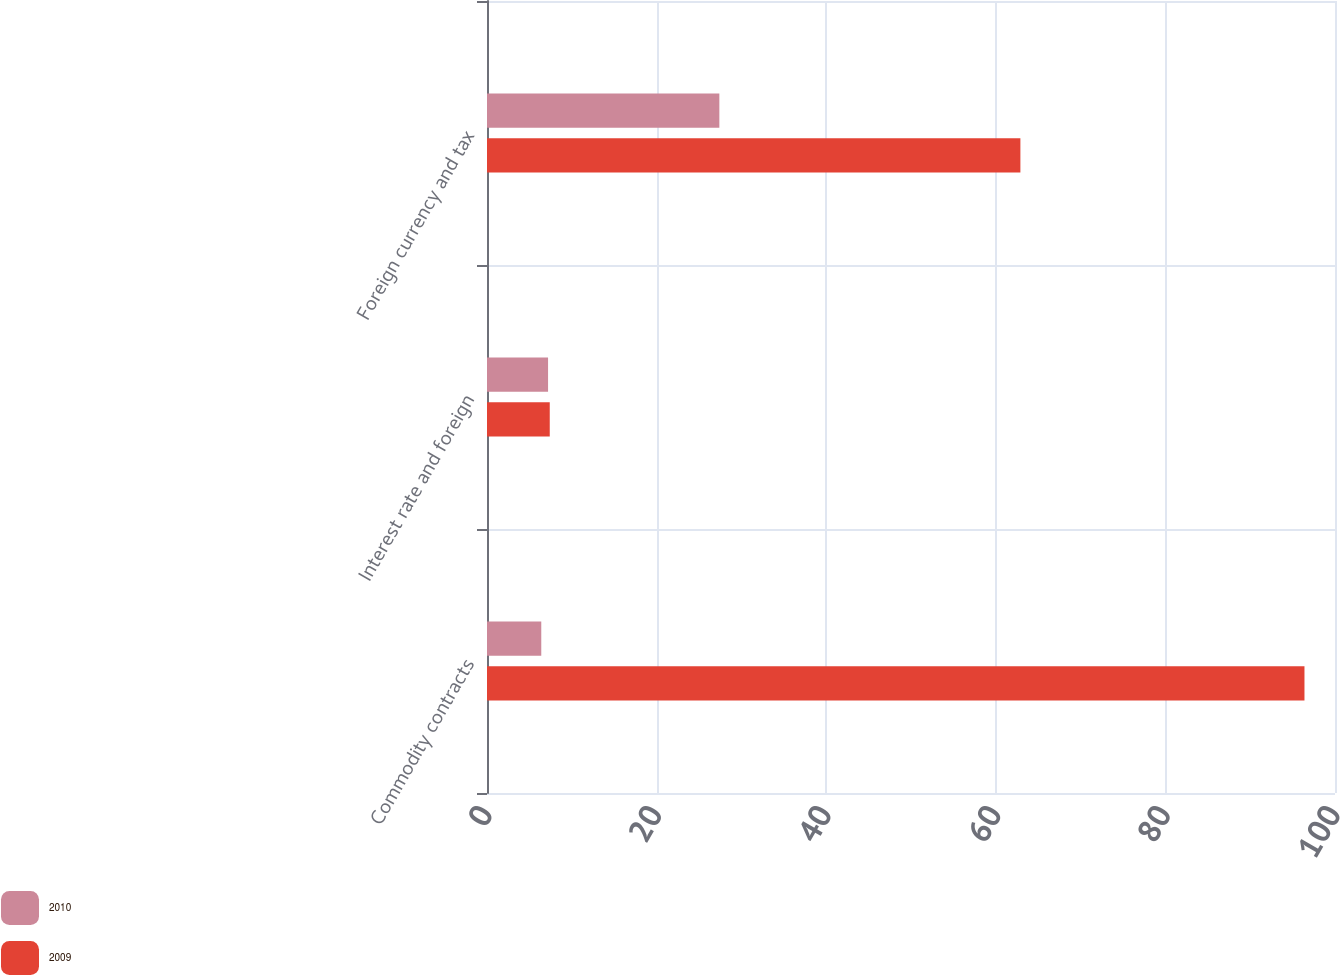Convert chart. <chart><loc_0><loc_0><loc_500><loc_500><stacked_bar_chart><ecel><fcel>Commodity contracts<fcel>Interest rate and foreign<fcel>Foreign currency and tax<nl><fcel>2010<fcel>6.4<fcel>7.2<fcel>27.4<nl><fcel>2009<fcel>96.4<fcel>7.4<fcel>62.9<nl></chart> 